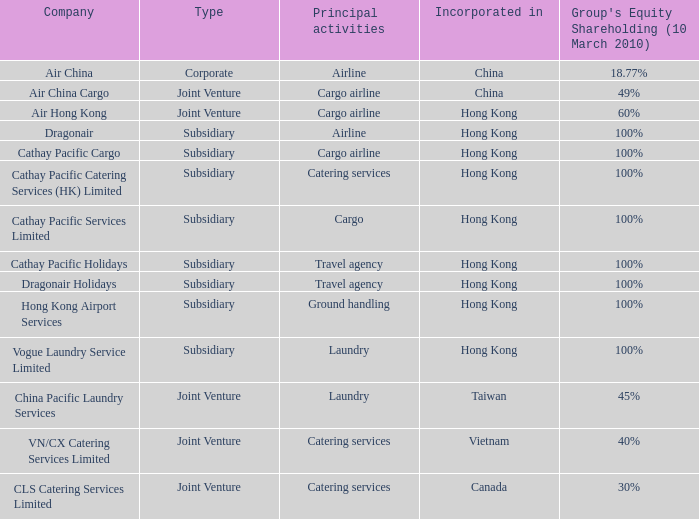What is the Group's equity share percentage for Company VN/CX catering services limited? 40%. Would you mind parsing the complete table? {'header': ['Company', 'Type', 'Principal activities', 'Incorporated in', "Group's Equity Shareholding (10 March 2010)"], 'rows': [['Air China', 'Corporate', 'Airline', 'China', '18.77%'], ['Air China Cargo', 'Joint Venture', 'Cargo airline', 'China', '49%'], ['Air Hong Kong', 'Joint Venture', 'Cargo airline', 'Hong Kong', '60%'], ['Dragonair', 'Subsidiary', 'Airline', 'Hong Kong', '100%'], ['Cathay Pacific Cargo', 'Subsidiary', 'Cargo airline', 'Hong Kong', '100%'], ['Cathay Pacific Catering Services (HK) Limited', 'Subsidiary', 'Catering services', 'Hong Kong', '100%'], ['Cathay Pacific Services Limited', 'Subsidiary', 'Cargo', 'Hong Kong', '100%'], ['Cathay Pacific Holidays', 'Subsidiary', 'Travel agency', 'Hong Kong', '100%'], ['Dragonair Holidays', 'Subsidiary', 'Travel agency', 'Hong Kong', '100%'], ['Hong Kong Airport Services', 'Subsidiary', 'Ground handling', 'Hong Kong', '100%'], ['Vogue Laundry Service Limited', 'Subsidiary', 'Laundry', 'Hong Kong', '100%'], ['China Pacific Laundry Services', 'Joint Venture', 'Laundry', 'Taiwan', '45%'], ['VN/CX Catering Services Limited', 'Joint Venture', 'Catering services', 'Vietnam', '40%'], ['CLS Catering Services Limited', 'Joint Venture', 'Catering services', 'Canada', '30%']]} 